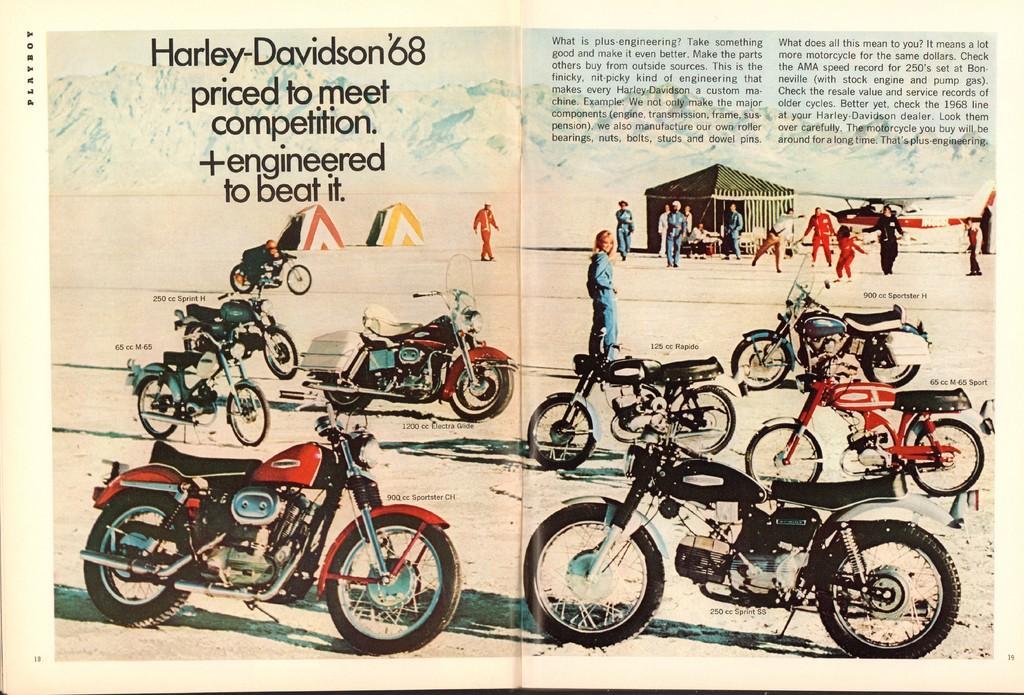In one or two sentences, can you explain what this image depicts? In this image there are bikes. There are people standing on the road. Behind them there is a house. On the right side of the image there is a helicopter. There is some text on the image. 